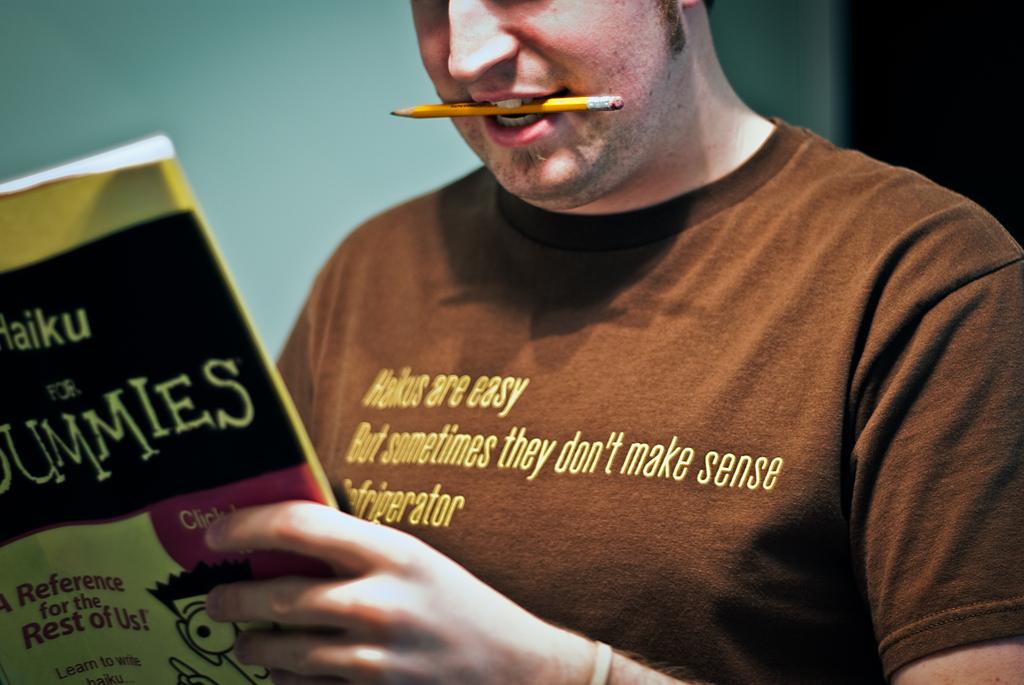What book is the person reading?
Provide a succinct answer. Haiku for dummies. Who is this a reference for?
Give a very brief answer. Dummies. 